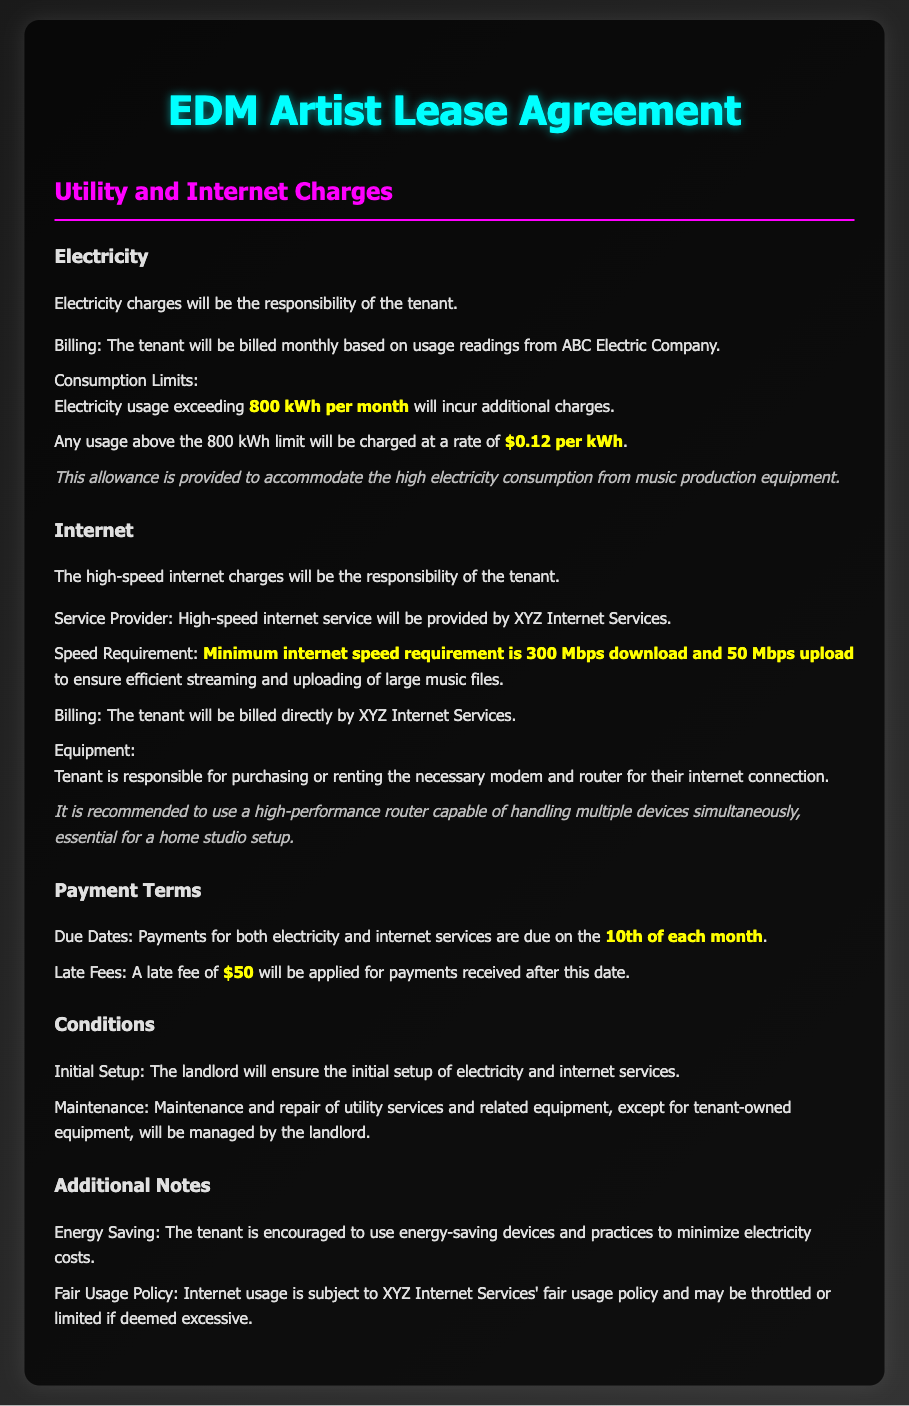What is the electricity usage limit per month? The document states that electricity usage exceeding 800 kWh per month will incur additional charges.
Answer: 800 kWh What is the charge for electricity usage above the limit? The document specifies that any usage above the 800 kWh limit will be charged at a rate of $0.12 per kWh.
Answer: $0.12 per kWh What is the minimum internet speed requirement? The document mentions that the minimum internet speed requirement is 300 Mbps download and 50 Mbps upload.
Answer: 300 Mbps download and 50 Mbps upload When are the utility payments due? According to the document, payments for both electricity and internet services are due on the 10th of each month.
Answer: 10th of each month What happens if the payment is late? The document outlines that a late fee of $50 will be applied for payments received after the due date.
Answer: $50 Who is responsible for internet service billing? The document indicates that the tenant will be billed directly by XYZ Internet Services for internet service.
Answer: Tenant What is recommended for the internet connection? The document recommends using a high-performance router capable of handling multiple devices simultaneously.
Answer: High-performance router What will the landlord ensure initially? The document states that the landlord will ensure the initial setup of electricity and internet services.
Answer: Initial setup What should the tenant use to minimize electricity costs? The document encourages the tenant to use energy-saving devices and practices.
Answer: Energy-saving devices 